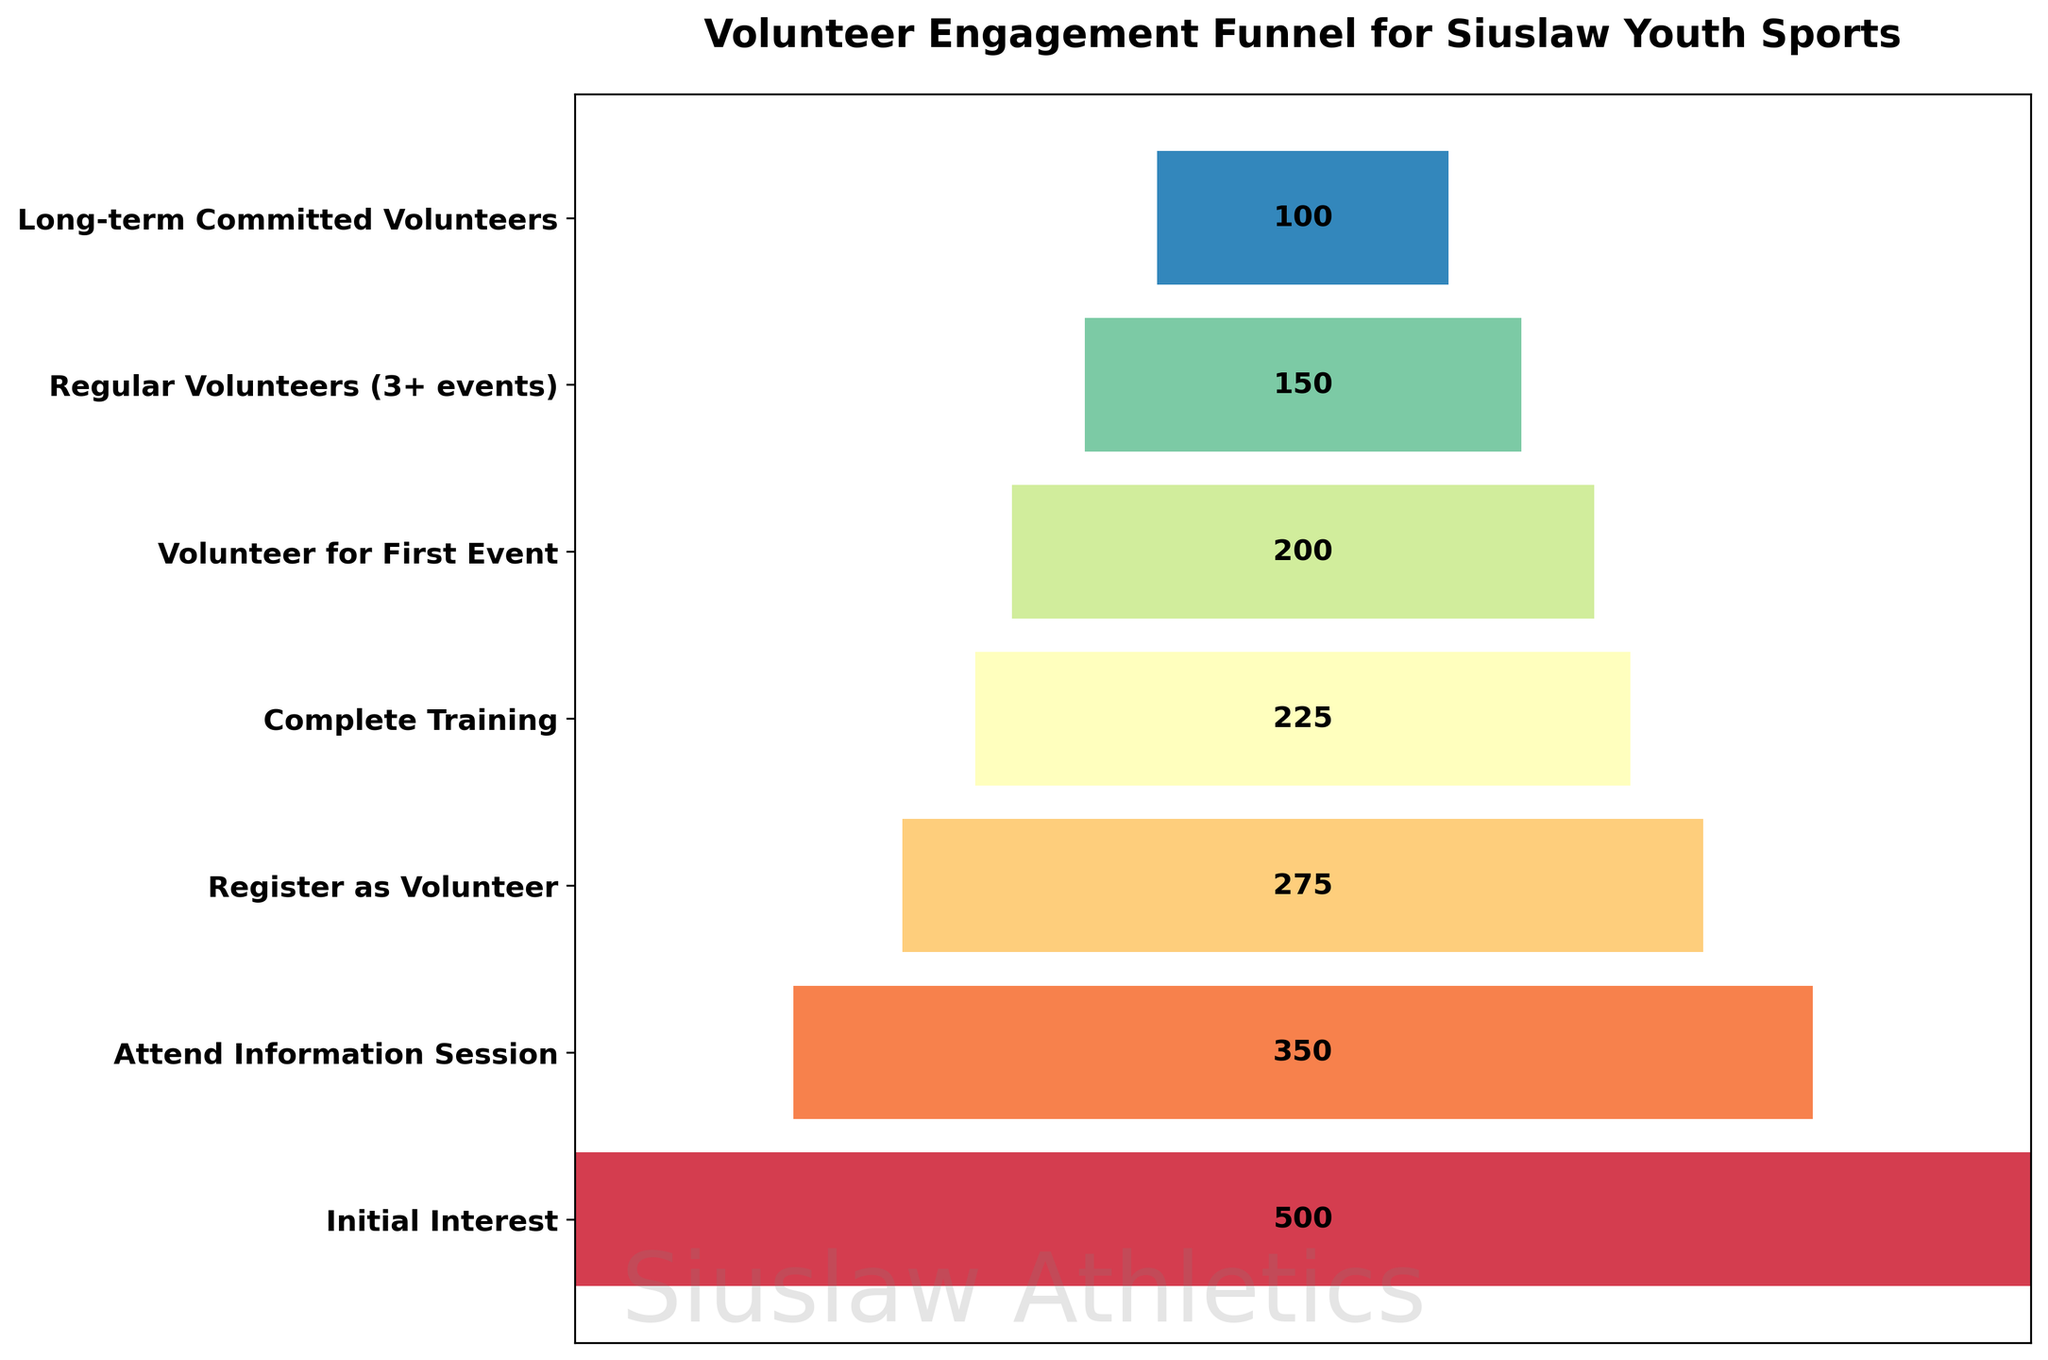How many stages are shown in the funnel chart? Count the number of different stages listed on the y-axis.
Answer: 7 What is the title of the figure? Look at the top of the figure for the text that describes the overall subject.
Answer: Volunteer Engagement Funnel for Siuslaw Youth Sports Which stage has the highest number of people? Refer to the bar that has the maximum width and check its associated stage label.
Answer: Initial Interest At which stage do we see people first start dropping off significantly? Compare the differences in the number of people between two consecutive stages and identify the largest initial drop.
Answer: Attend Information Session How many more people completed training compared to those who volunteered for the first event? Subtract the number of volunteers for the first event from the number of people who completed training (225 - 200).
Answer: 25 What percentage of those who showed initial interest become long-term committed volunteers? Divide the number of long-term committed volunteers by the number of people with initial interest, then multiply by 100. (100 / 500) * 100
Answer: 20% What is the color theme used in the funnel chart? Identify the range or palette of colors used in the bars visually.
Answer: Spectral How many people dropped out between attending the information session and registering as a volunteer? Subtract the number of people who registered as volunteers from the number who attended the information session (350 - 275).
Answer: 75 Which stage has the smallest number of people? Refer to the bar that has the minimum width and check its associated stage label.
Answer: Long-term Committed Volunteers Between Regular Volunteers and Long-term Committed Volunteers, what is the percentage decrease? Calculate the decrease as a percentage: ((150 - 100) / 150) * 100.
Answer: 33.33% 